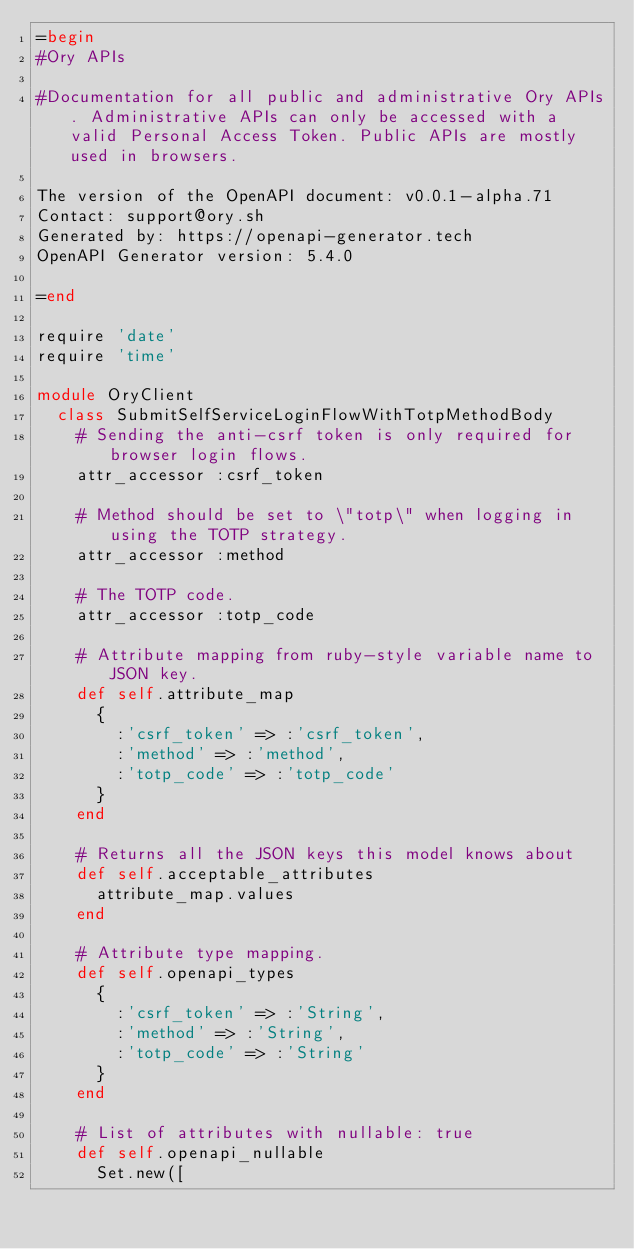Convert code to text. <code><loc_0><loc_0><loc_500><loc_500><_Ruby_>=begin
#Ory APIs

#Documentation for all public and administrative Ory APIs. Administrative APIs can only be accessed with a valid Personal Access Token. Public APIs are mostly used in browsers. 

The version of the OpenAPI document: v0.0.1-alpha.71
Contact: support@ory.sh
Generated by: https://openapi-generator.tech
OpenAPI Generator version: 5.4.0

=end

require 'date'
require 'time'

module OryClient
  class SubmitSelfServiceLoginFlowWithTotpMethodBody
    # Sending the anti-csrf token is only required for browser login flows.
    attr_accessor :csrf_token

    # Method should be set to \"totp\" when logging in using the TOTP strategy.
    attr_accessor :method

    # The TOTP code.
    attr_accessor :totp_code

    # Attribute mapping from ruby-style variable name to JSON key.
    def self.attribute_map
      {
        :'csrf_token' => :'csrf_token',
        :'method' => :'method',
        :'totp_code' => :'totp_code'
      }
    end

    # Returns all the JSON keys this model knows about
    def self.acceptable_attributes
      attribute_map.values
    end

    # Attribute type mapping.
    def self.openapi_types
      {
        :'csrf_token' => :'String',
        :'method' => :'String',
        :'totp_code' => :'String'
      }
    end

    # List of attributes with nullable: true
    def self.openapi_nullable
      Set.new([</code> 